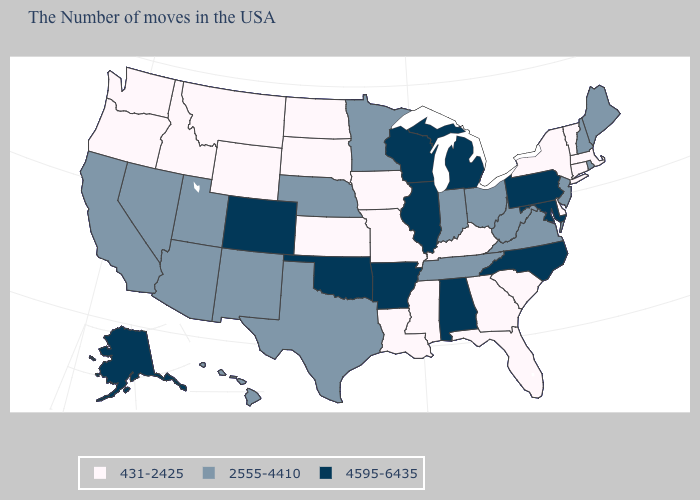What is the lowest value in the MidWest?
Concise answer only. 431-2425. Name the states that have a value in the range 2555-4410?
Short answer required. Maine, Rhode Island, New Hampshire, New Jersey, Virginia, West Virginia, Ohio, Indiana, Tennessee, Minnesota, Nebraska, Texas, New Mexico, Utah, Arizona, Nevada, California, Hawaii. Which states hav the highest value in the West?
Quick response, please. Colorado, Alaska. What is the value of Wyoming?
Keep it brief. 431-2425. Does Indiana have the lowest value in the MidWest?
Write a very short answer. No. Does Utah have the same value as Wyoming?
Concise answer only. No. Among the states that border Idaho , does Nevada have the highest value?
Write a very short answer. Yes. What is the highest value in the USA?
Concise answer only. 4595-6435. Does New Hampshire have the same value as Iowa?
Keep it brief. No. Which states hav the highest value in the West?
Quick response, please. Colorado, Alaska. What is the highest value in states that border Maryland?
Give a very brief answer. 4595-6435. Name the states that have a value in the range 431-2425?
Write a very short answer. Massachusetts, Vermont, Connecticut, New York, Delaware, South Carolina, Florida, Georgia, Kentucky, Mississippi, Louisiana, Missouri, Iowa, Kansas, South Dakota, North Dakota, Wyoming, Montana, Idaho, Washington, Oregon. Which states have the highest value in the USA?
Concise answer only. Maryland, Pennsylvania, North Carolina, Michigan, Alabama, Wisconsin, Illinois, Arkansas, Oklahoma, Colorado, Alaska. What is the value of Nevada?
Answer briefly. 2555-4410. What is the highest value in the MidWest ?
Short answer required. 4595-6435. 